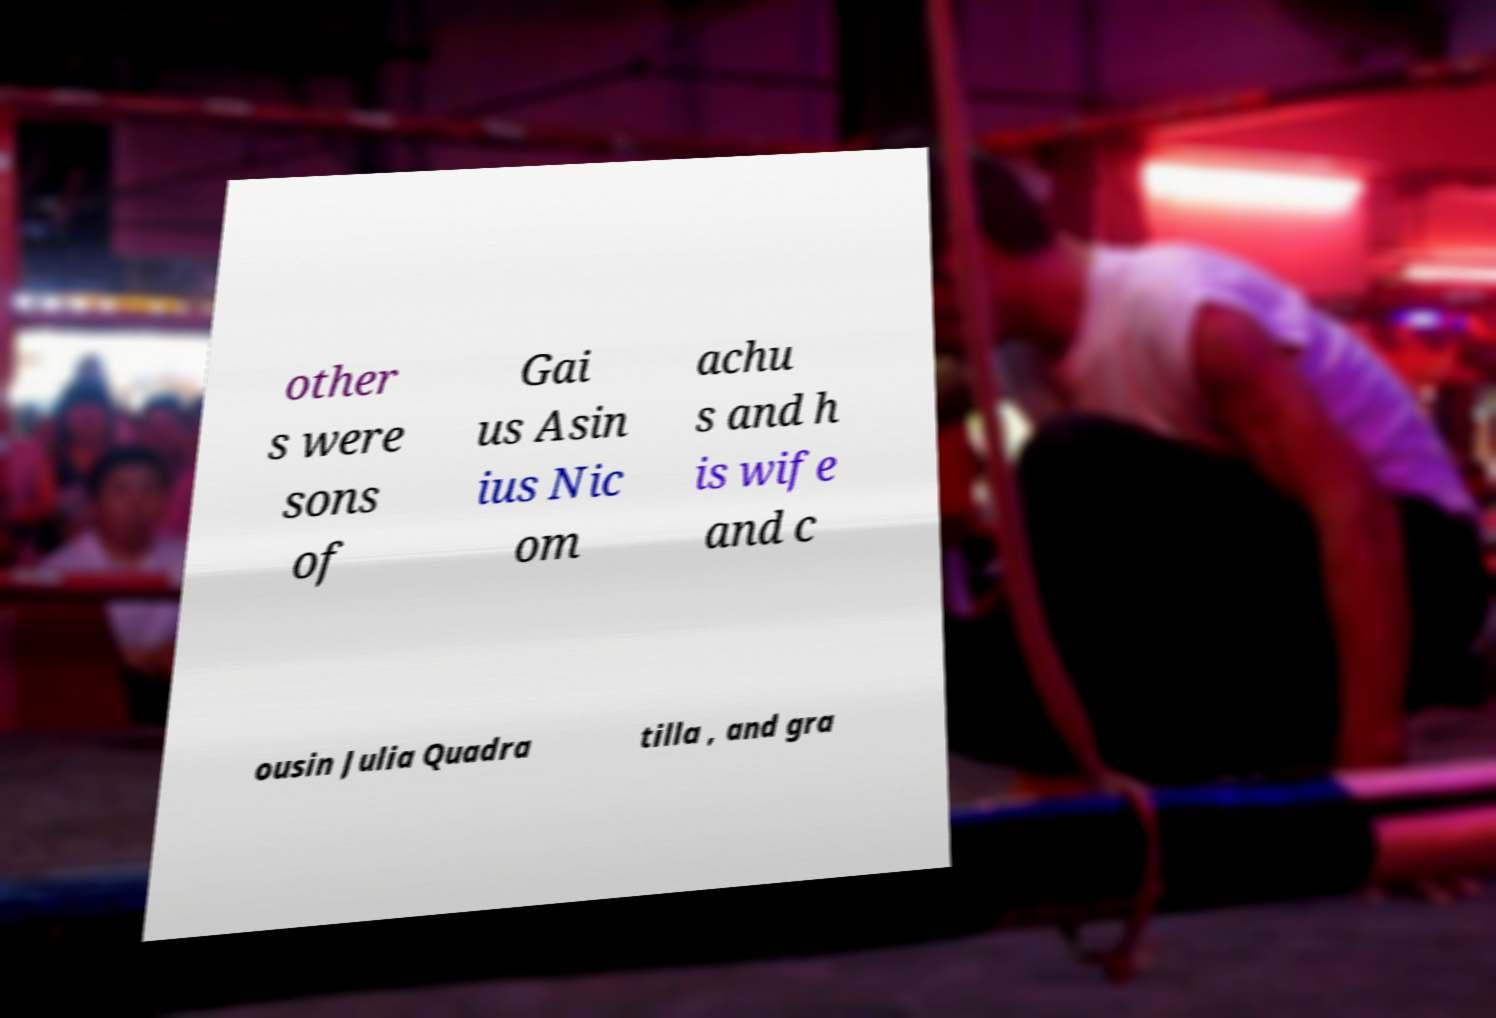There's text embedded in this image that I need extracted. Can you transcribe it verbatim? other s were sons of Gai us Asin ius Nic om achu s and h is wife and c ousin Julia Quadra tilla , and gra 